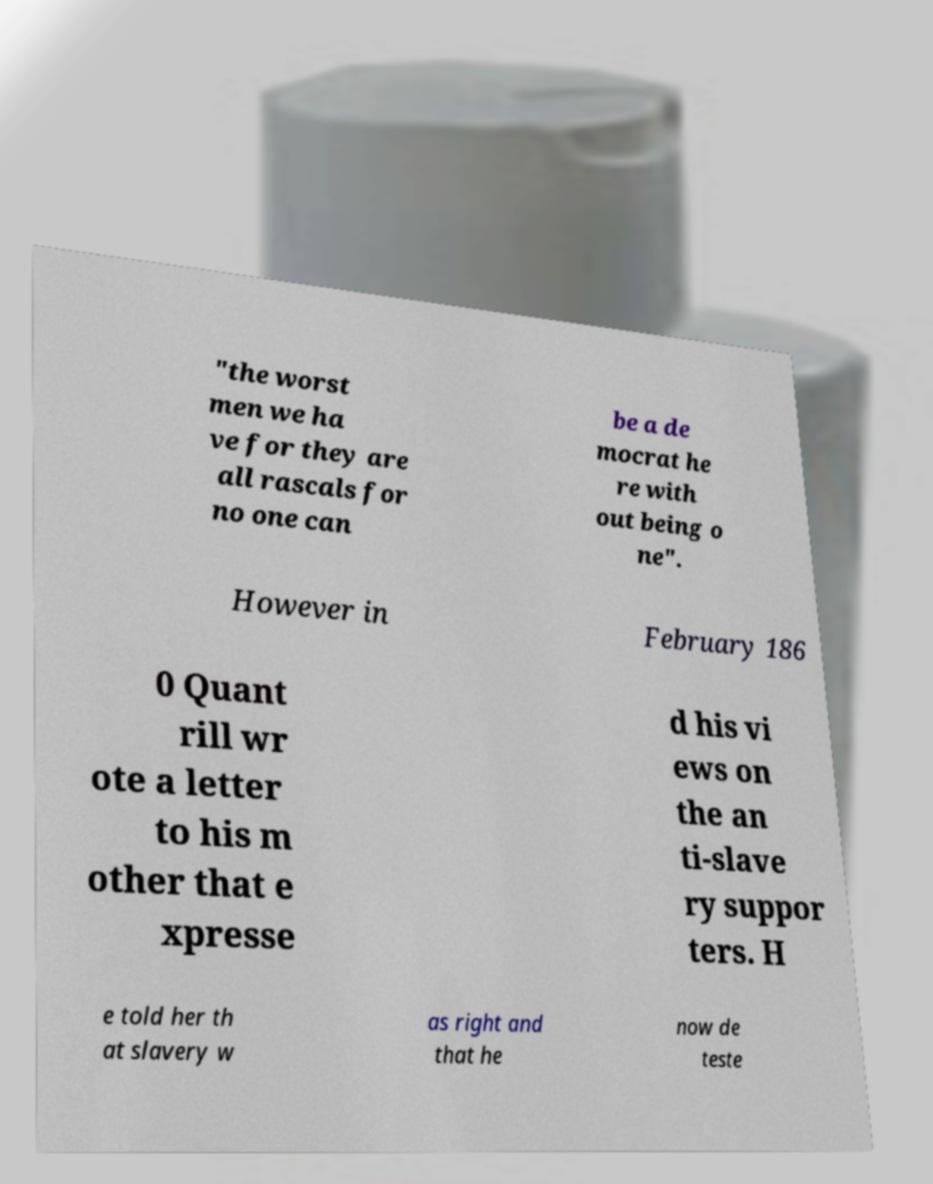What messages or text are displayed in this image? I need them in a readable, typed format. "the worst men we ha ve for they are all rascals for no one can be a de mocrat he re with out being o ne". However in February 186 0 Quant rill wr ote a letter to his m other that e xpresse d his vi ews on the an ti-slave ry suppor ters. H e told her th at slavery w as right and that he now de teste 